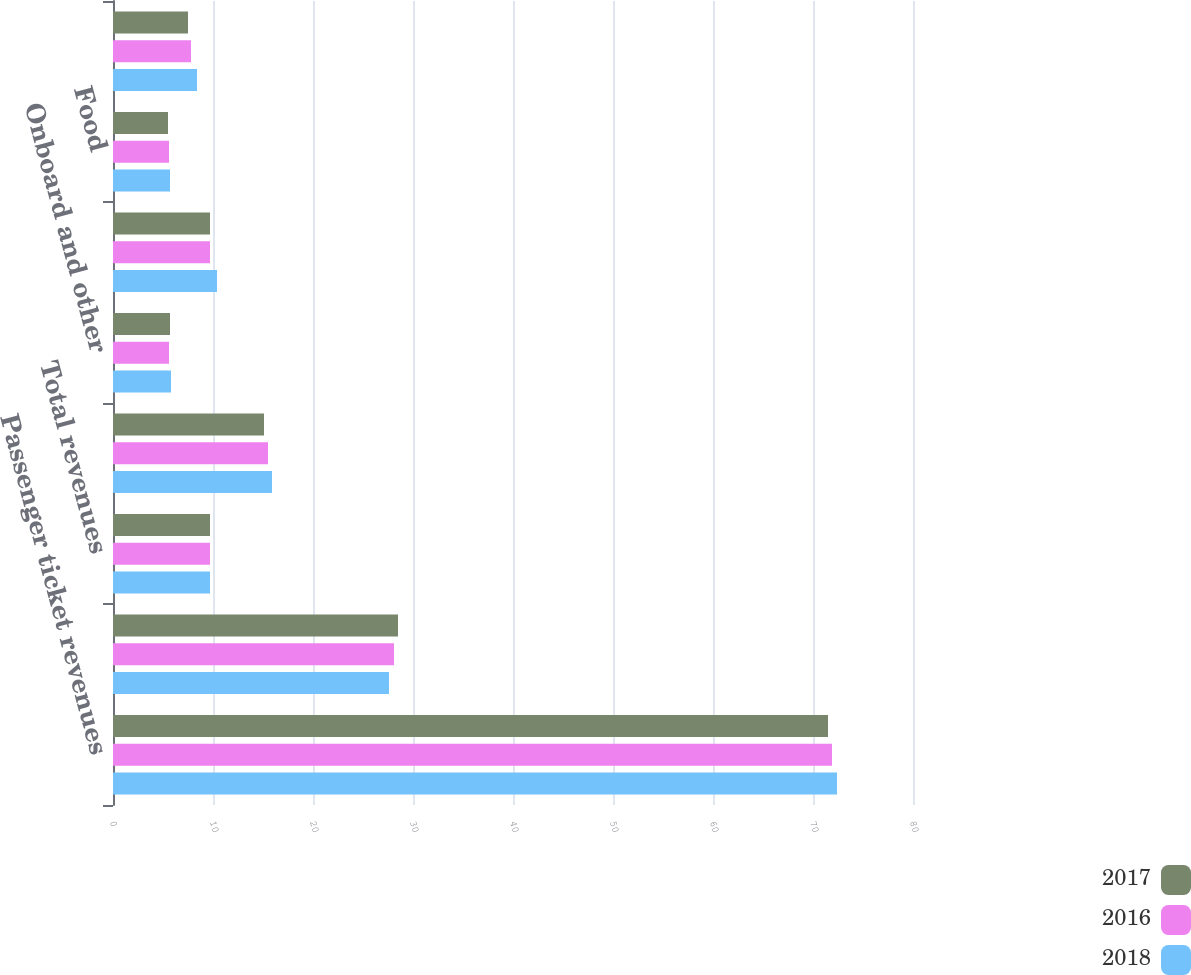Convert chart. <chart><loc_0><loc_0><loc_500><loc_500><stacked_bar_chart><ecel><fcel>Passenger ticket revenues<fcel>Onboard and other revenues<fcel>Total revenues<fcel>Commissions transportation and<fcel>Onboard and other<fcel>Payroll and related<fcel>Food<fcel>Fuel<nl><fcel>2017<fcel>71.5<fcel>28.5<fcel>9.7<fcel>15.1<fcel>5.7<fcel>9.7<fcel>5.5<fcel>7.5<nl><fcel>2016<fcel>71.9<fcel>28.1<fcel>9.7<fcel>15.5<fcel>5.6<fcel>9.7<fcel>5.6<fcel>7.8<nl><fcel>2018<fcel>72.4<fcel>27.6<fcel>9.7<fcel>15.9<fcel>5.8<fcel>10.4<fcel>5.7<fcel>8.4<nl></chart> 